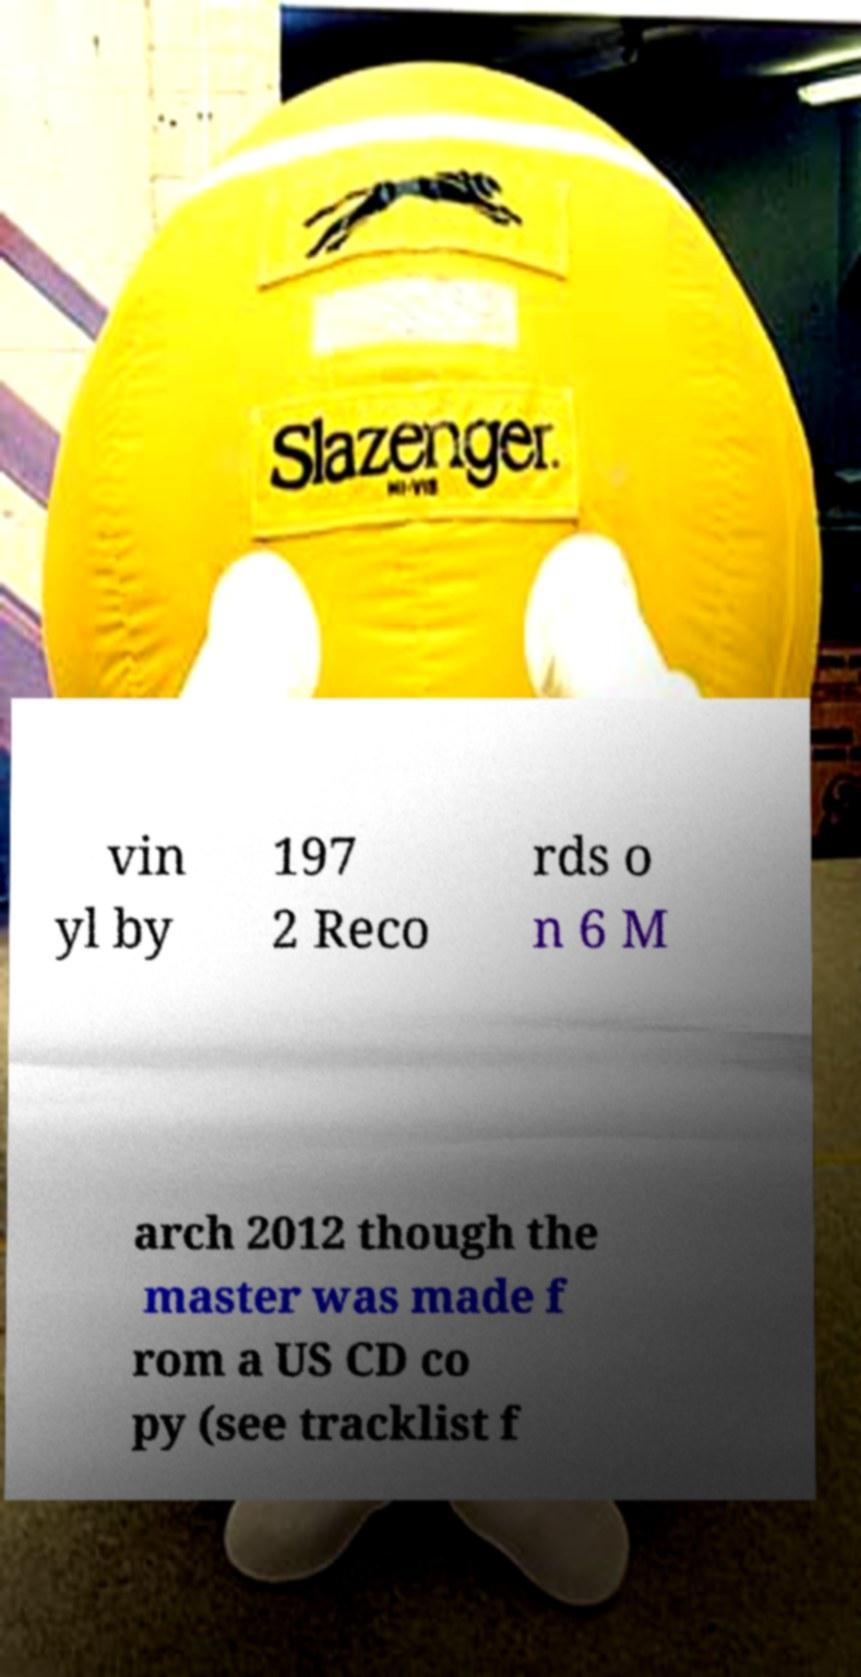Could you assist in decoding the text presented in this image and type it out clearly? vin yl by 197 2 Reco rds o n 6 M arch 2012 though the master was made f rom a US CD co py (see tracklist f 